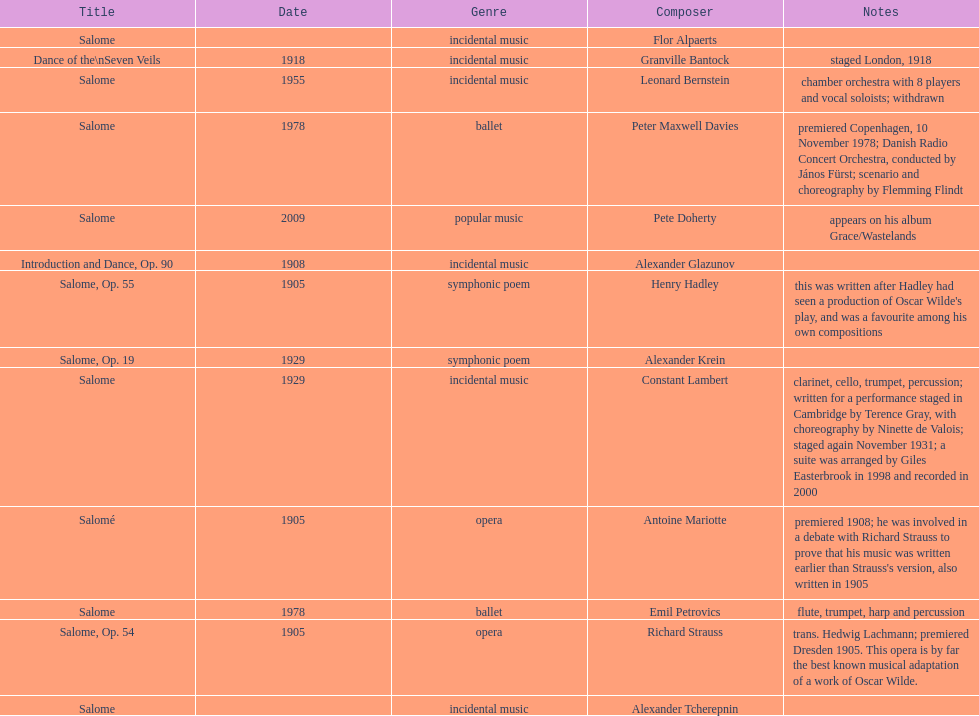Which composer produced his title after 2001? Pete Doherty. 